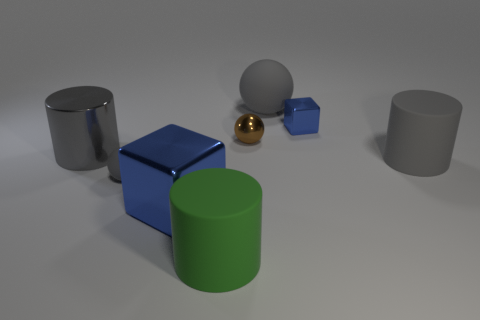Add 2 gray metal objects. How many objects exist? 10 Subtract all cubes. How many objects are left? 6 Subtract 0 green cubes. How many objects are left? 8 Subtract all large green objects. Subtract all blue metallic things. How many objects are left? 5 Add 7 gray spheres. How many gray spheres are left? 9 Add 5 yellow rubber balls. How many yellow rubber balls exist? 5 